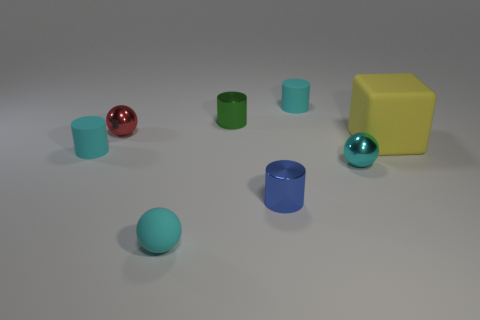Add 1 brown metallic balls. How many objects exist? 9 Subtract all balls. How many objects are left? 5 Add 5 tiny green shiny cylinders. How many tiny green shiny cylinders are left? 6 Add 7 cyan blocks. How many cyan blocks exist? 7 Subtract 0 red blocks. How many objects are left? 8 Subtract all small rubber objects. Subtract all yellow objects. How many objects are left? 4 